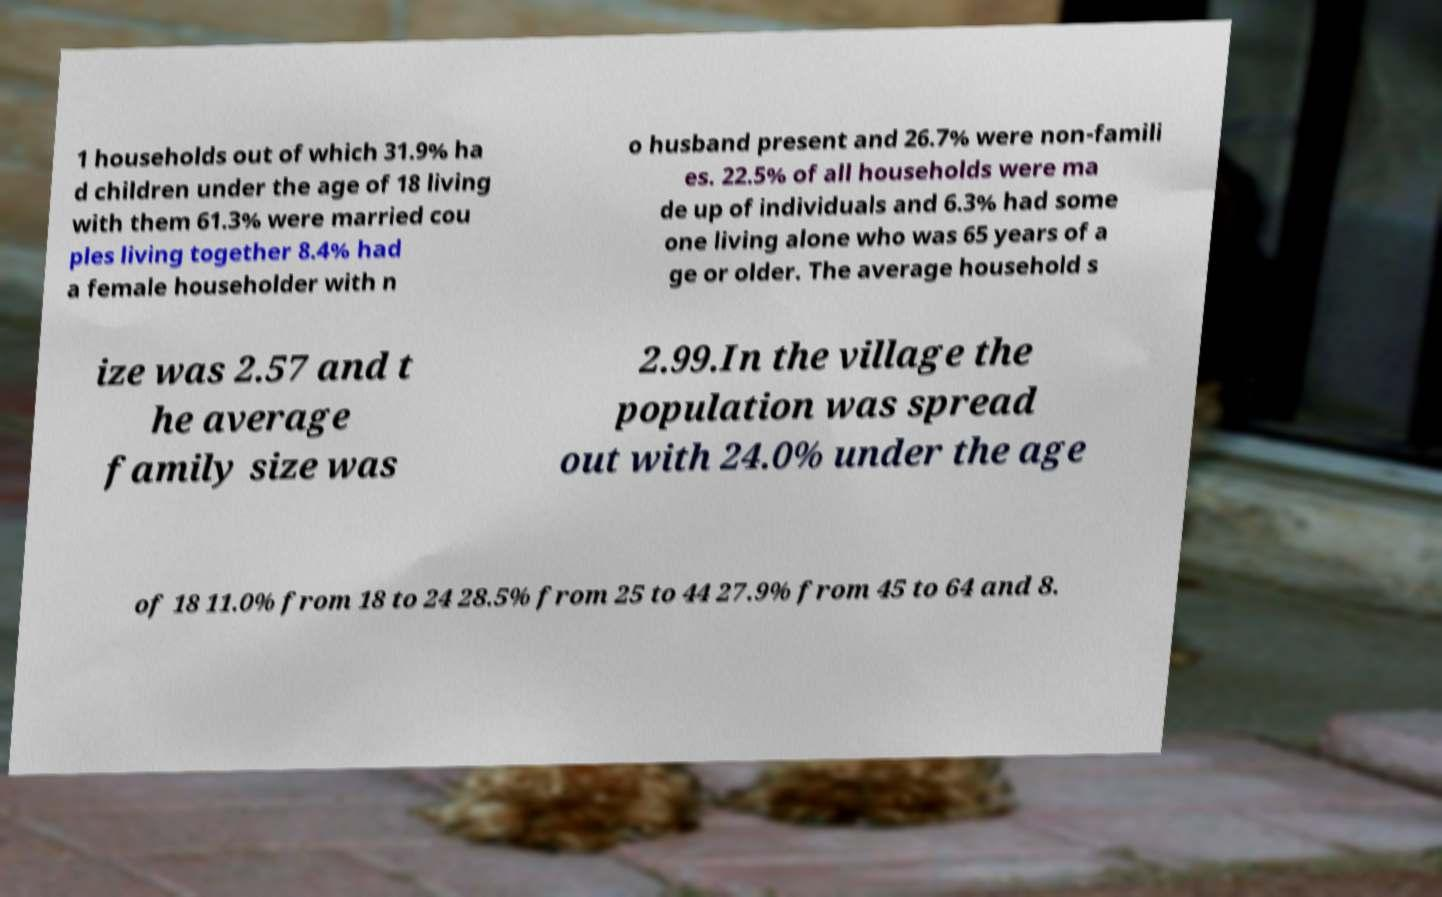Can you accurately transcribe the text from the provided image for me? 1 households out of which 31.9% ha d children under the age of 18 living with them 61.3% were married cou ples living together 8.4% had a female householder with n o husband present and 26.7% were non-famili es. 22.5% of all households were ma de up of individuals and 6.3% had some one living alone who was 65 years of a ge or older. The average household s ize was 2.57 and t he average family size was 2.99.In the village the population was spread out with 24.0% under the age of 18 11.0% from 18 to 24 28.5% from 25 to 44 27.9% from 45 to 64 and 8. 